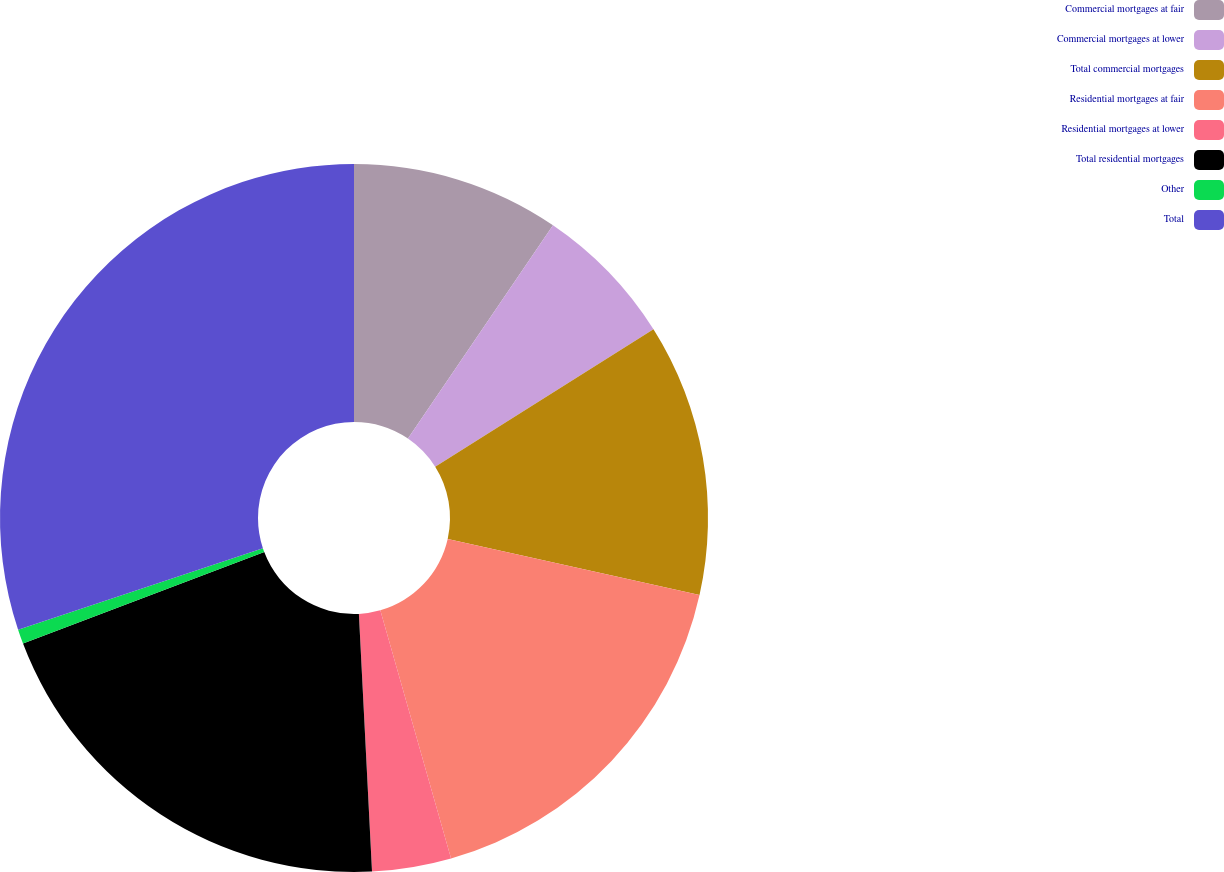Convert chart to OTSL. <chart><loc_0><loc_0><loc_500><loc_500><pie_chart><fcel>Commercial mortgages at fair<fcel>Commercial mortgages at lower<fcel>Total commercial mortgages<fcel>Residential mortgages at fair<fcel>Residential mortgages at lower<fcel>Total residential mortgages<fcel>Other<fcel>Total<nl><fcel>9.5%<fcel>6.55%<fcel>12.44%<fcel>17.09%<fcel>3.61%<fcel>20.04%<fcel>0.66%<fcel>30.11%<nl></chart> 